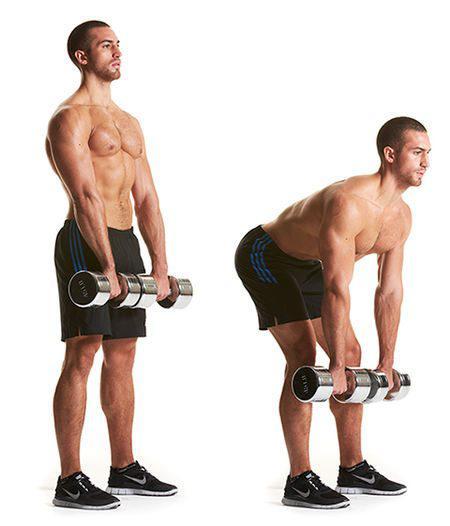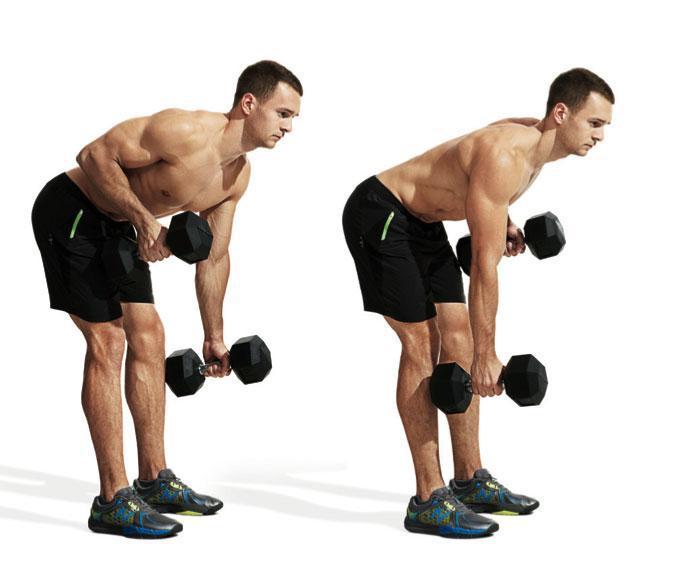The first image is the image on the left, the second image is the image on the right. Examine the images to the left and right. Is the description "There are exactly two men in the image on the right." accurate? Answer yes or no. Yes. 